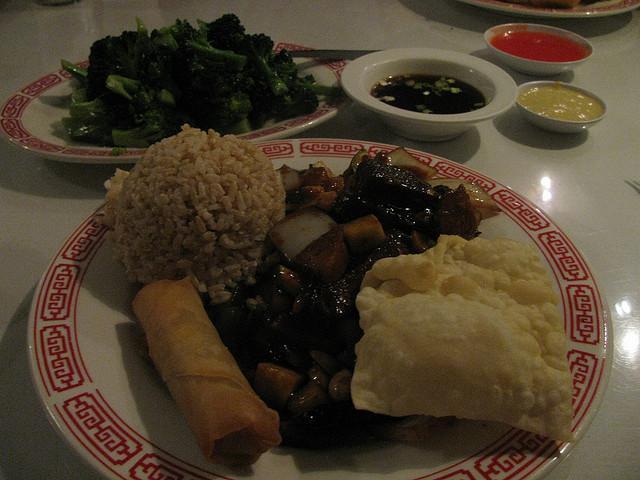What is used to sook the food?
Make your selection from the four choices given to correctly answer the question.
Options: Light, sun, coal, stove. Stove. 